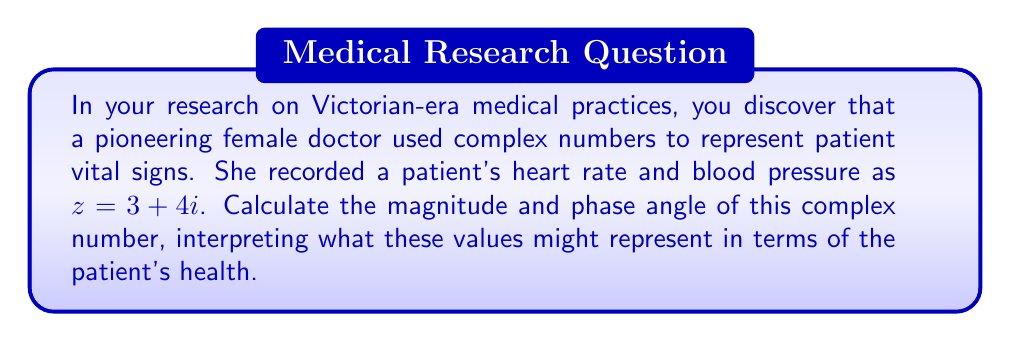Could you help me with this problem? Let's approach this step-by-step:

1) For a complex number $z = a + bi$, the magnitude (or modulus) is given by:
   
   $|z| = \sqrt{a^2 + b^2}$

2) In this case, $z = 3 + 4i$, so $a = 3$ and $b = 4$. Let's calculate the magnitude:
   
   $|z| = \sqrt{3^2 + 4^2} = \sqrt{9 + 16} = \sqrt{25} = 5$

3) The phase angle $\theta$ (in radians) is given by:
   
   $\theta = \tan^{-1}(\frac{b}{a})$

4) Calculating the phase angle:
   
   $\theta = \tan^{-1}(\frac{4}{3}) \approx 0.9273$ radians

5) To convert radians to degrees, multiply by $\frac{180}{\pi}$:
   
   $\theta \approx 0.9273 \times \frac{180}{\pi} \approx 53.13°$

Interpretation:
The magnitude (5) could represent the overall intensity of the vital signs. A higher number might indicate more extreme readings, potentially concerning for the patient's health.

The phase angle (53.13°) could represent the balance between the two vital signs. An angle closer to 45° might indicate a balance, while angles far from 45° could suggest one vital sign is significantly higher than the other.
Answer: Magnitude: 5, Phase angle: 53.13° 